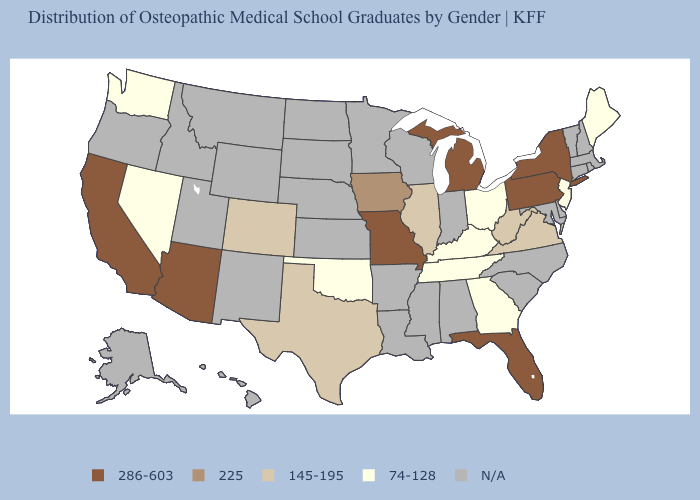Among the states that border Nebraska , does Missouri have the lowest value?
Give a very brief answer. No. What is the value of Kansas?
Write a very short answer. N/A. What is the value of Pennsylvania?
Give a very brief answer. 286-603. Among the states that border Wisconsin , does Illinois have the highest value?
Be succinct. No. Does Colorado have the highest value in the USA?
Keep it brief. No. Name the states that have a value in the range N/A?
Quick response, please. Alabama, Alaska, Arkansas, Connecticut, Delaware, Hawaii, Idaho, Indiana, Kansas, Louisiana, Maryland, Massachusetts, Minnesota, Mississippi, Montana, Nebraska, New Hampshire, New Mexico, North Carolina, North Dakota, Oregon, Rhode Island, South Carolina, South Dakota, Utah, Vermont, Wisconsin, Wyoming. What is the lowest value in states that border Idaho?
Keep it brief. 74-128. What is the highest value in states that border Indiana?
Keep it brief. 286-603. What is the value of North Carolina?
Be succinct. N/A. What is the lowest value in the Northeast?
Give a very brief answer. 74-128. What is the value of Maryland?
Give a very brief answer. N/A. What is the lowest value in the USA?
Keep it brief. 74-128. 